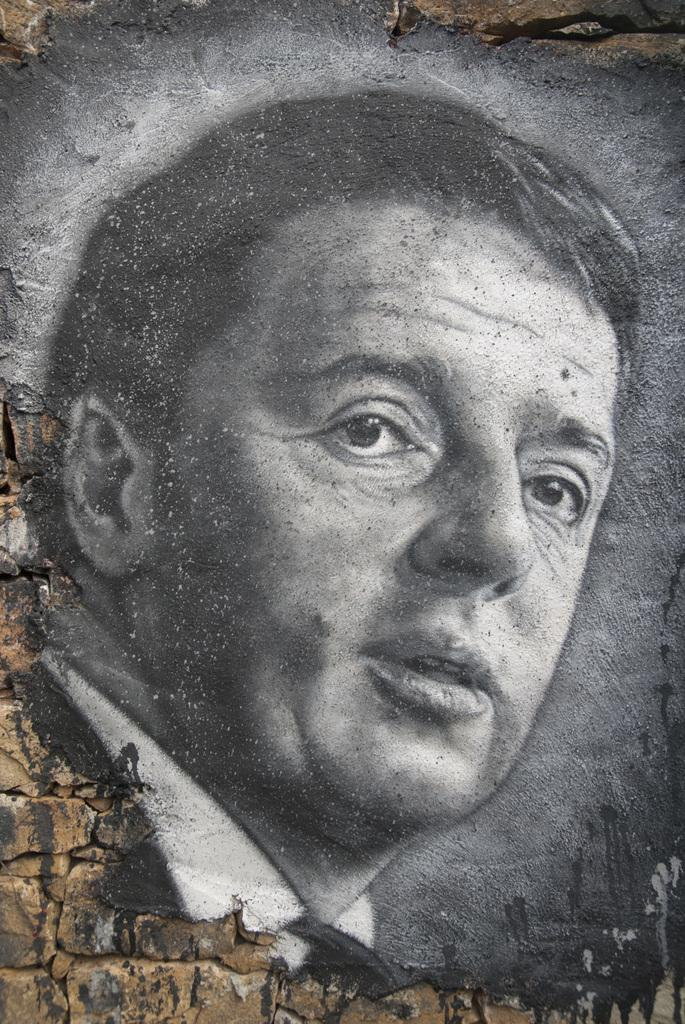What is depicted on the wall in the center of the image? There is an art piece of a person on the wall in the center of the image. What type of natural elements can be seen in the image? There are rocks visible in the image. What type of clam is being managed by the person in the art piece? There is no clam or person managing a clam present in the image; it only features an art piece of a person and rocks. 